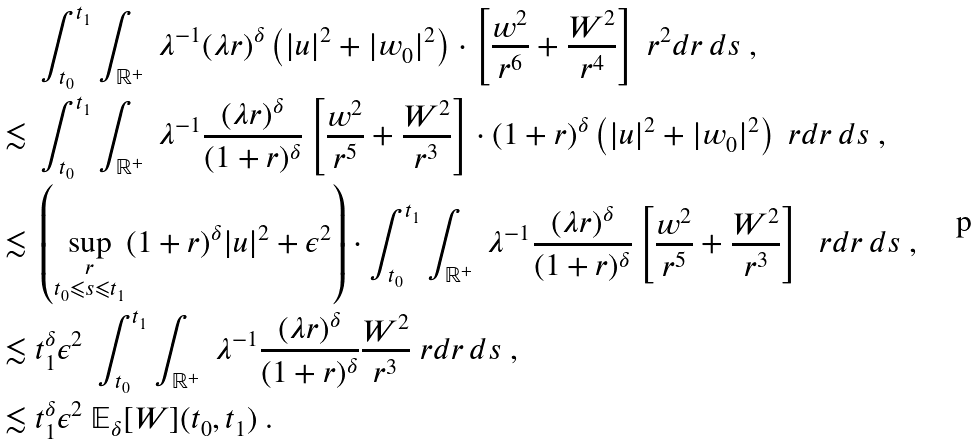<formula> <loc_0><loc_0><loc_500><loc_500>& \int _ { t _ { 0 } } ^ { t _ { 1 } } \int _ { \mathbb { R } ^ { + } } \ \lambda ^ { - 1 } ( \lambda r ) ^ { \delta } \left ( | u | ^ { 2 } + | w _ { 0 } | ^ { 2 } \right ) \cdot \left [ \frac { w ^ { 2 } } { r ^ { 6 } } + \frac { W ^ { 2 } } { r ^ { 4 } } \right ] \ r ^ { 2 } d r \, d s \ , \\ \lesssim \ & \int _ { t _ { 0 } } ^ { t _ { 1 } } \int _ { \mathbb { R } ^ { + } } \ \lambda ^ { - 1 } \frac { ( \lambda r ) ^ { \delta } } { ( 1 + r ) ^ { \delta } } \left [ \frac { w ^ { 2 } } { r ^ { 5 } } + \frac { W ^ { 2 } } { r ^ { 3 } } \right ] \cdot ( 1 + r ) ^ { \delta } \left ( | u | ^ { 2 } + | w _ { 0 } | ^ { 2 } \right ) \ r d r \, d s \ , \\ \lesssim \ & \left ( \sup _ { \substack { r \\ t _ { 0 } \leqslant s \leqslant t _ { 1 } } } ( 1 + r ) ^ { \delta } | u | ^ { 2 } + \epsilon ^ { 2 } \right ) \cdot \int _ { t _ { 0 } } ^ { t _ { 1 } } \int _ { \mathbb { R } ^ { + } } \ \lambda ^ { - 1 } \frac { ( \lambda r ) ^ { \delta } } { ( 1 + r ) ^ { \delta } } \left [ \frac { w ^ { 2 } } { r ^ { 5 } } + \frac { W ^ { 2 } } { r ^ { 3 } } \right ] \ \ r d r \, d s \ , \\ \lesssim \ & t _ { 1 } ^ { \delta } \epsilon ^ { 2 } \ \int _ { t _ { 0 } } ^ { t _ { 1 } } \int _ { \mathbb { R } ^ { + } } \ \lambda ^ { - 1 } \frac { ( \lambda r ) ^ { \delta } } { ( 1 + r ) ^ { \delta } } \frac { W ^ { 2 } } { r ^ { 3 } } \ r d r \, d s \ , \\ \lesssim \ & t _ { 1 } ^ { \delta } \epsilon ^ { 2 } \ \mathbb { E } _ { \delta } [ W ] ( t _ { 0 } , t _ { 1 } ) \ .</formula> 